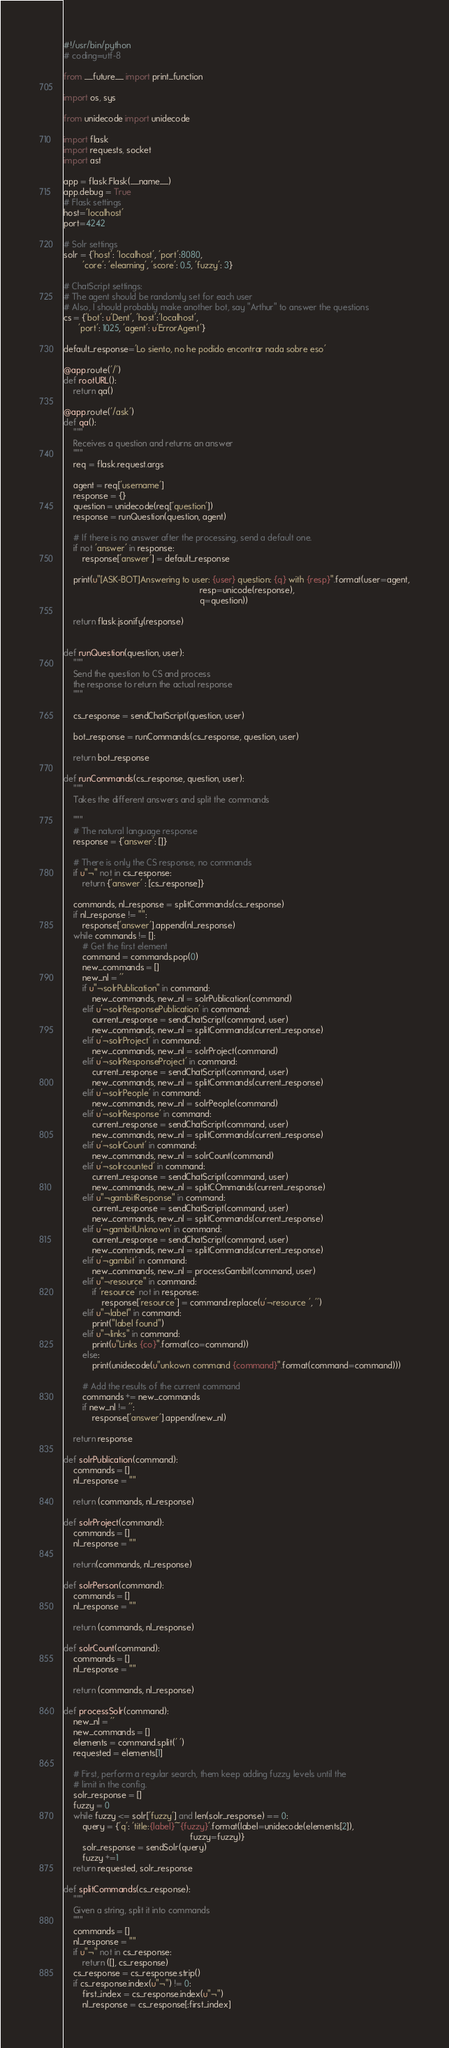<code> <loc_0><loc_0><loc_500><loc_500><_Python_>#!/usr/bin/python
# coding=utf-8

from __future__ import print_function

import os, sys

from unidecode import unidecode

import flask
import requests, socket
import ast

app = flask.Flask(__name__)
app.debug = True
# Flask settings 
host='localhost'
port=4242

# Solr settings
solr = {'host': 'localhost', 'port':8080, 
        'core': 'elearning', 'score': 0.5, 'fuzzy': 3}

# ChatScript settings:
# The agent should be randomly set for each user
# Also, I should probably make another bot, say "Arthur" to answer the questions
cs = {'bot': u'Dent', 'host':'localhost',
      'port': 1025, 'agent': u'ErrorAgent'}

default_response='Lo siento, no he podido encontrar nada sobre eso'

@app.route('/')
def rootURL():
    return qa()

@app.route('/ask')
def qa():
    """
    Receives a question and returns an answer
    """
    req = flask.request.args
    
    agent = req['username']
    response = {}
    question = unidecode(req['question'])
    response = runQuestion(question, agent)
    
    # If there is no answer after the processing, send a default one.
    if not 'answer' in response:
        response['answer'] = default_response
    
    print(u"[ASK-BOT]Answering to user: {user} question: {q} with {resp}".format(user=agent,
                                                         resp=unicode(response),
                                                         q=question))
    
    return flask.jsonify(response)


def runQuestion(question, user):
    """
    Send the question to CS and process
    the response to return the actual response
    """

    cs_response = sendChatScript(question, user)

    bot_response = runCommands(cs_response, question, user)
    
    return bot_response

def runCommands(cs_response, question, user):
    """
    Takes the different answers and split the commands
    
    """
    # The natural language response
    response = {'answer': []}

    # There is only the CS response, no commands
    if u"¬" not in cs_response:
        return {'answer' : [cs_response]}
    
    commands, nl_response = splitCommands(cs_response)
    if nl_response != "":
        response['answer'].append(nl_response)
    while commands != []:
        # Get the first element
        command = commands.pop(0)
        new_commands = []
        new_nl = ''
        if u"¬solrPublication" in command:
            new_commands, new_nl = solrPublication(command)
        elif u'¬solrResponsePublication' in command:
            current_response = sendChatScript(command, user)
            new_commands, new_nl = splitCommands(current_response)
        elif u'¬solrProject' in command:
            new_commands, new_nl = solrProject(command)
        elif u'¬solrResponseProject' in command:
            current_response = sendChatScript(command, user)
            new_commands, new_nl = splitCommands(current_response)
        elif u'¬solrPeople' in command:
            new_commands, new_nl = solrPeople(command)
        elif u'¬solrResponse' in command:
            current_response = sendChatScript(command, user)
            new_commands, new_nl = splitCommands(current_response)
        elif u'¬solrCount' in command:
            new_commands, new_nl = solrCount(command)
        elif u'¬solrcounted' in command:
            current_response = sendChatScript(command, user)
            new_commands, new_nl = splitCOmmands(current_response)
        elif u"¬gambitResponse" in command:
            current_response = sendChatScript(command, user)
            new_commands, new_nl = splitCommands(current_response)
        elif u'¬gambitUnknown' in command:
            current_response = sendChatScript(command, user)
            new_commands, new_nl = splitCommands(current_response)
        elif u'¬gambit' in command:
            new_commands, new_nl = processGambit(command, user)
        elif u"¬resource" in command:
            if 'resource' not in response:
                response['resource'] = command.replace(u'¬resource ', '')
        elif u"¬label" in command:
            print("label found")
        elif u"¬links" in command:
            print(u"Links {co}".format(co=command))
        else:
            print(unidecode(u"unkown command {command}".format(command=command)))
        
        # Add the results of the current command
        commands += new_commands
        if new_nl != '':
            response['answer'].append(new_nl)
 
    return response

def solrPublication(command):
    commands = []
    nl_response = ""

    return (commands, nl_response)

def solrProject(command):
    commands = []
    nl_response = ""

    return(commands, nl_response)

def solrPerson(command):
    commands = []
    nl_response = ""

    return (commands, nl_response)

def solrCount(command):
    commands = []
    nl_response = ""

    return (commands, nl_response)

def processSolr(command):
    new_nl = ''
    new_commands = []
    elements = command.split(' ')
    requested = elements[1]
    
    # First, perform a regular search, them keep adding fuzzy levels until the
    # limit in the config.
    solr_response = []
    fuzzy = 0 
    while fuzzy <= solr['fuzzy'] and len(solr_response) == 0:
        query = {'q': 'title:{label}~{fuzzy}'.format(label=unidecode(elements[2]),
                                                     fuzzy=fuzzy)}
        solr_response = sendSolr(query)
        fuzzy +=1
    return requested, solr_response
    
def splitCommands(cs_response):
    """
    Given a string, split it into commands
    """
    commands = []
    nl_response = ""
    if u"¬" not in cs_response:
        return ([], cs_response)
    cs_response = cs_response.strip()
    if cs_response.index(u"¬") != 0:
        first_index = cs_response.index(u"¬")
        nl_response = cs_response[:first_index]</code> 